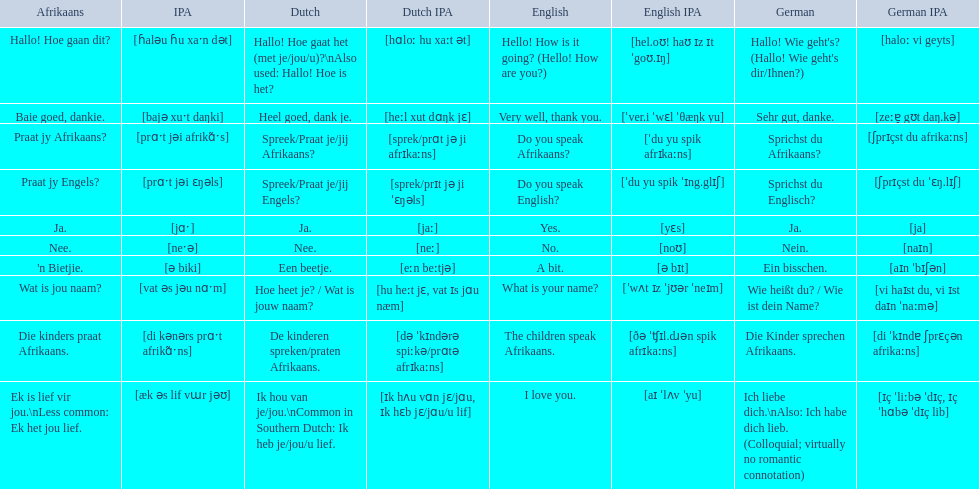What are all of the afrikaans phrases shown in the table? Hallo! Hoe gaan dit?, Baie goed, dankie., Praat jy Afrikaans?, Praat jy Engels?, Ja., Nee., 'n Bietjie., Wat is jou naam?, Die kinders praat Afrikaans., Ek is lief vir jou.\nLess common: Ek het jou lief. Of those, which translates into english as do you speak afrikaans?? Praat jy Afrikaans?. 